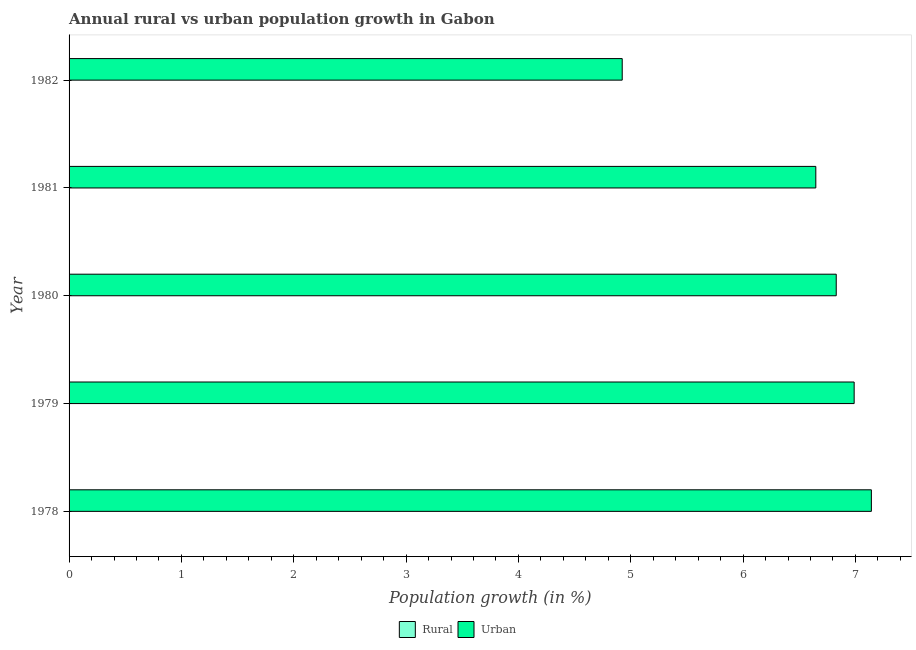How many bars are there on the 2nd tick from the bottom?
Ensure brevity in your answer.  1. What is the label of the 3rd group of bars from the top?
Keep it short and to the point. 1980. What is the rural population growth in 1982?
Offer a very short reply. 0. Across all years, what is the maximum urban population growth?
Your answer should be very brief. 7.14. Across all years, what is the minimum urban population growth?
Your answer should be compact. 4.92. In which year was the urban population growth maximum?
Provide a succinct answer. 1978. What is the total urban population growth in the graph?
Give a very brief answer. 32.53. What is the difference between the urban population growth in 1979 and that in 1981?
Offer a terse response. 0.34. What is the difference between the urban population growth in 1982 and the rural population growth in 1979?
Your answer should be very brief. 4.92. What is the average urban population growth per year?
Offer a very short reply. 6.51. In how many years, is the urban population growth greater than 5.4 %?
Provide a succinct answer. 4. What is the ratio of the urban population growth in 1978 to that in 1981?
Provide a succinct answer. 1.07. What is the difference between the highest and the second highest urban population growth?
Offer a very short reply. 0.15. What is the difference between the highest and the lowest urban population growth?
Provide a succinct answer. 2.22. In how many years, is the rural population growth greater than the average rural population growth taken over all years?
Make the answer very short. 0. Are all the bars in the graph horizontal?
Ensure brevity in your answer.  Yes. How many years are there in the graph?
Your answer should be very brief. 5. Are the values on the major ticks of X-axis written in scientific E-notation?
Offer a very short reply. No. Does the graph contain any zero values?
Keep it short and to the point. Yes. How many legend labels are there?
Offer a terse response. 2. How are the legend labels stacked?
Make the answer very short. Horizontal. What is the title of the graph?
Your response must be concise. Annual rural vs urban population growth in Gabon. What is the label or title of the X-axis?
Give a very brief answer. Population growth (in %). What is the Population growth (in %) in Urban  in 1978?
Your response must be concise. 7.14. What is the Population growth (in %) in Urban  in 1979?
Provide a succinct answer. 6.99. What is the Population growth (in %) of Rural in 1980?
Provide a succinct answer. 0. What is the Population growth (in %) in Urban  in 1980?
Offer a very short reply. 6.83. What is the Population growth (in %) in Urban  in 1981?
Offer a very short reply. 6.65. What is the Population growth (in %) of Urban  in 1982?
Your answer should be compact. 4.92. Across all years, what is the maximum Population growth (in %) of Urban ?
Make the answer very short. 7.14. Across all years, what is the minimum Population growth (in %) of Urban ?
Your answer should be very brief. 4.92. What is the total Population growth (in %) in Urban  in the graph?
Your response must be concise. 32.53. What is the difference between the Population growth (in %) in Urban  in 1978 and that in 1979?
Your response must be concise. 0.15. What is the difference between the Population growth (in %) in Urban  in 1978 and that in 1980?
Offer a very short reply. 0.31. What is the difference between the Population growth (in %) of Urban  in 1978 and that in 1981?
Your response must be concise. 0.49. What is the difference between the Population growth (in %) of Urban  in 1978 and that in 1982?
Offer a terse response. 2.22. What is the difference between the Population growth (in %) of Urban  in 1979 and that in 1980?
Make the answer very short. 0.16. What is the difference between the Population growth (in %) in Urban  in 1979 and that in 1981?
Your answer should be very brief. 0.34. What is the difference between the Population growth (in %) in Urban  in 1979 and that in 1982?
Your response must be concise. 2.06. What is the difference between the Population growth (in %) in Urban  in 1980 and that in 1981?
Offer a terse response. 0.18. What is the difference between the Population growth (in %) in Urban  in 1980 and that in 1982?
Offer a terse response. 1.91. What is the difference between the Population growth (in %) in Urban  in 1981 and that in 1982?
Your response must be concise. 1.72. What is the average Population growth (in %) in Rural per year?
Your answer should be very brief. 0. What is the average Population growth (in %) of Urban  per year?
Your answer should be very brief. 6.51. What is the ratio of the Population growth (in %) of Urban  in 1978 to that in 1979?
Make the answer very short. 1.02. What is the ratio of the Population growth (in %) of Urban  in 1978 to that in 1980?
Your answer should be very brief. 1.05. What is the ratio of the Population growth (in %) of Urban  in 1978 to that in 1981?
Give a very brief answer. 1.07. What is the ratio of the Population growth (in %) of Urban  in 1978 to that in 1982?
Your answer should be very brief. 1.45. What is the ratio of the Population growth (in %) of Urban  in 1979 to that in 1980?
Your response must be concise. 1.02. What is the ratio of the Population growth (in %) of Urban  in 1979 to that in 1981?
Keep it short and to the point. 1.05. What is the ratio of the Population growth (in %) of Urban  in 1979 to that in 1982?
Make the answer very short. 1.42. What is the ratio of the Population growth (in %) in Urban  in 1980 to that in 1981?
Provide a succinct answer. 1.03. What is the ratio of the Population growth (in %) in Urban  in 1980 to that in 1982?
Provide a short and direct response. 1.39. What is the ratio of the Population growth (in %) in Urban  in 1981 to that in 1982?
Your response must be concise. 1.35. What is the difference between the highest and the second highest Population growth (in %) in Urban ?
Ensure brevity in your answer.  0.15. What is the difference between the highest and the lowest Population growth (in %) in Urban ?
Your answer should be very brief. 2.22. 